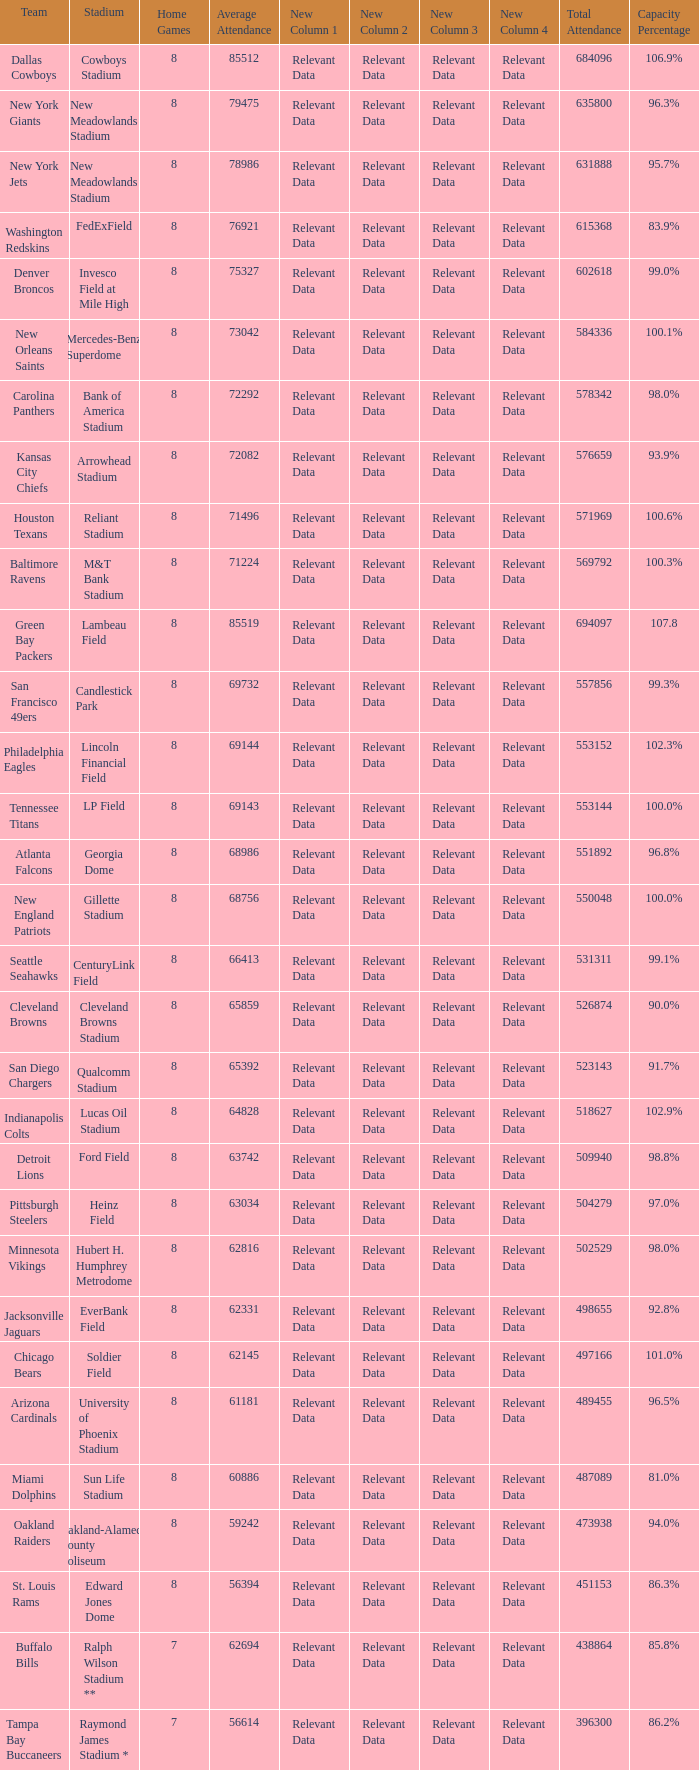What is the number listed in home games when the team is Seattle Seahawks? 8.0. 